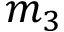Convert formula to latex. <formula><loc_0><loc_0><loc_500><loc_500>m _ { 3 }</formula> 